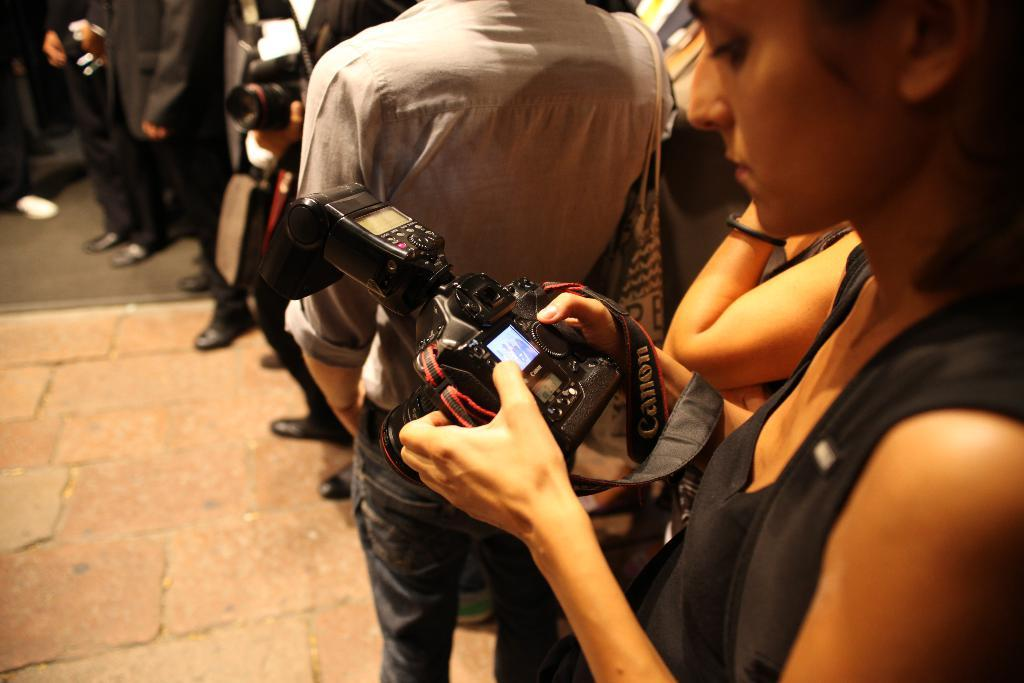What is the main subject of the image? The main subject of the image is a group of people. Where are the people located in the image? The people are standing on the ground. Can you describe the woman in the front of the group? The woman in the front of the group is holding a camera in her hands. What else is the woman wearing besides the camera? The woman is wearing a bag. What type of porter is helping the woman with her camera in the image? There is no porter present in the image, nor is anyone helping the woman with her camera. How many pockets can be seen on the woman's clothing in the image? The number of pockets on the woman's clothing cannot be determined from the image. 